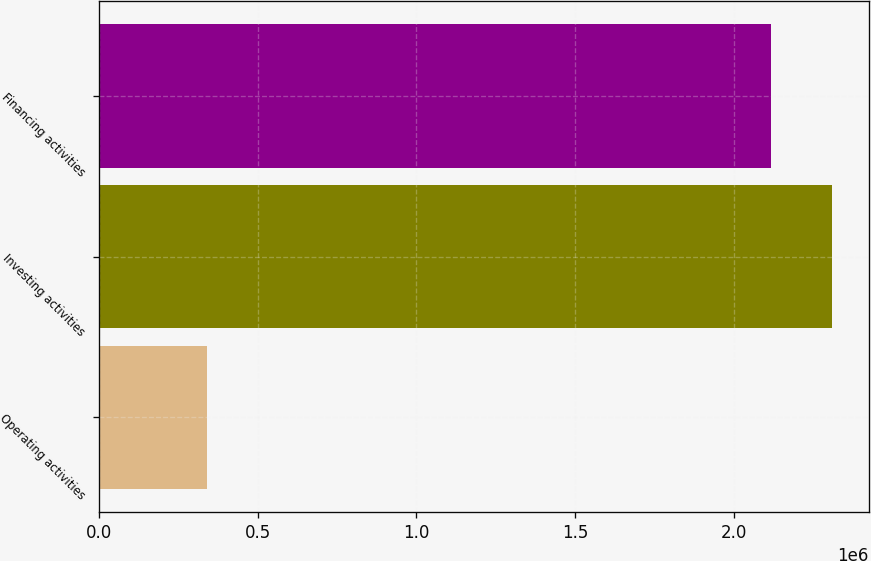<chart> <loc_0><loc_0><loc_500><loc_500><bar_chart><fcel>Operating activities<fcel>Investing activities<fcel>Financing activities<nl><fcel>340914<fcel>2.30983e+06<fcel>2.11641e+06<nl></chart> 